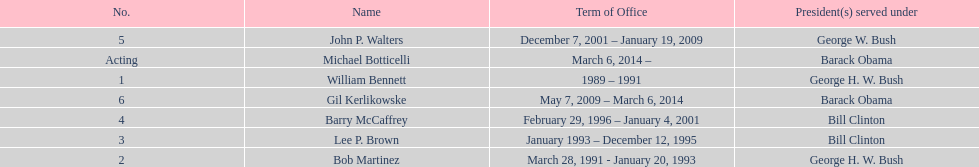I'm looking to parse the entire table for insights. Could you assist me with that? {'header': ['No.', 'Name', 'Term of Office', 'President(s) served under'], 'rows': [['5', 'John P. Walters', 'December 7, 2001 – January 19, 2009', 'George W. Bush'], ['Acting', 'Michael Botticelli', 'March 6, 2014 –', 'Barack Obama'], ['1', 'William Bennett', '1989 – 1991', 'George H. W. Bush'], ['6', 'Gil Kerlikowske', 'May 7, 2009 – March 6, 2014', 'Barack Obama'], ['4', 'Barry McCaffrey', 'February 29, 1996 – January 4, 2001', 'Bill Clinton'], ['3', 'Lee P. Brown', 'January 1993 – December 12, 1995', 'Bill Clinton'], ['2', 'Bob Martinez', 'March 28, 1991 - January 20, 1993', 'George H. W. Bush']]} What were the number of directors that stayed in office more than three years? 3. 